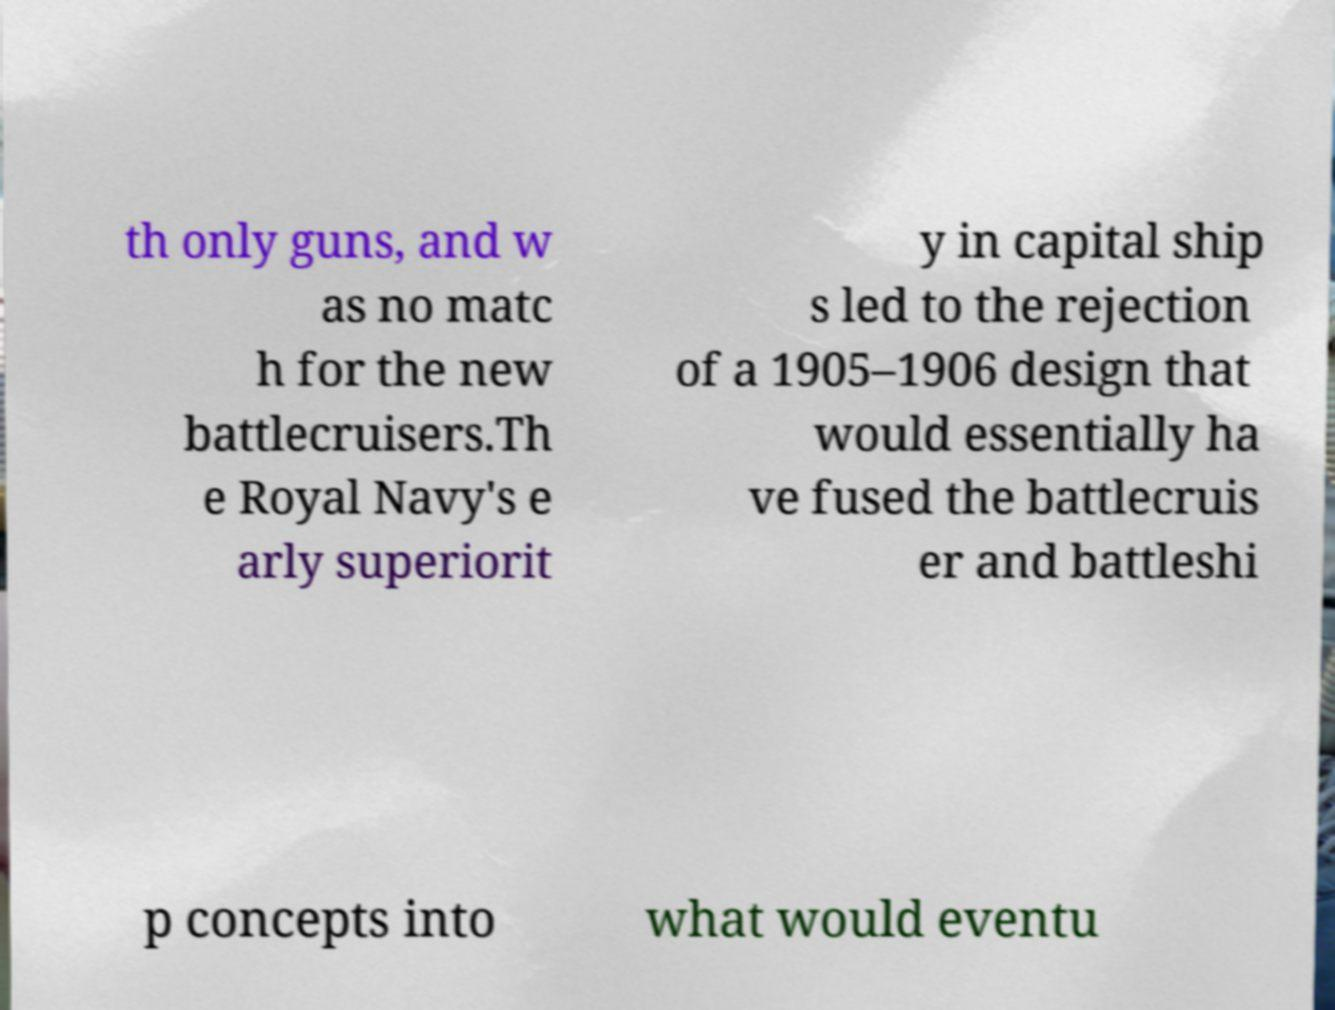What messages or text are displayed in this image? I need them in a readable, typed format. th only guns, and w as no matc h for the new battlecruisers.Th e Royal Navy's e arly superiorit y in capital ship s led to the rejection of a 1905–1906 design that would essentially ha ve fused the battlecruis er and battleshi p concepts into what would eventu 